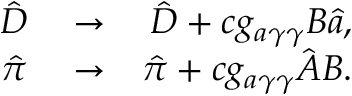Convert formula to latex. <formula><loc_0><loc_0><loc_500><loc_500>\begin{array} { r l r } { \hat { \boldsymbol D } } & \rightarrow } & { \hat { \boldsymbol D } + c g _ { a \gamma \gamma } { \boldsymbol B } \hat { a } , } \\ { \hat { \pi } } & \rightarrow } & { \hat { \pi } + c g _ { a \gamma \gamma } \hat { \boldsymbol A } { \boldsymbol B } . } \end{array}</formula> 